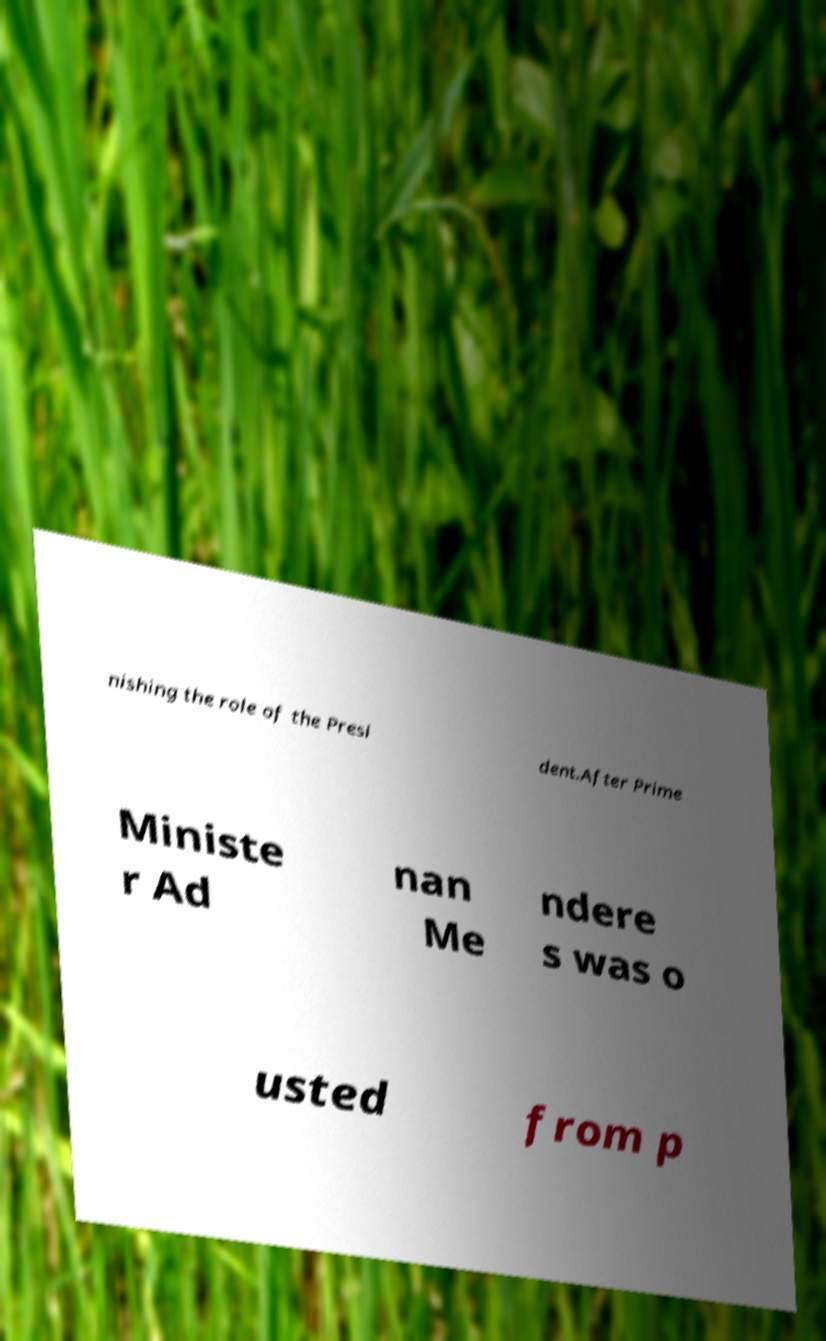I need the written content from this picture converted into text. Can you do that? nishing the role of the Presi dent.After Prime Ministe r Ad nan Me ndere s was o usted from p 